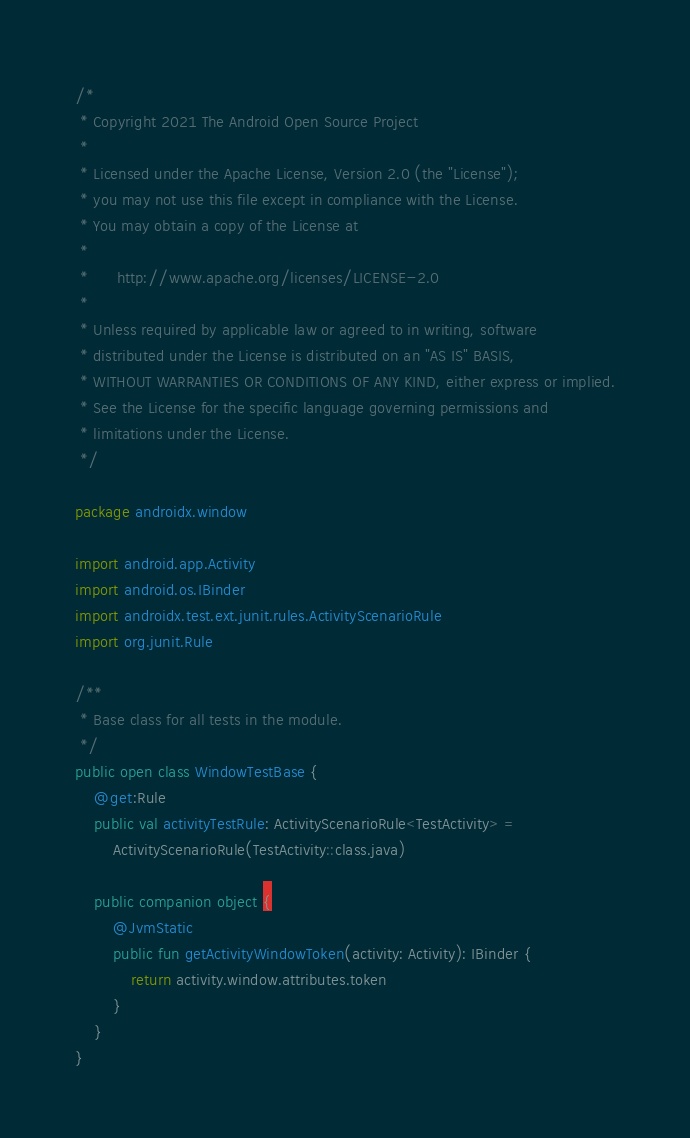Convert code to text. <code><loc_0><loc_0><loc_500><loc_500><_Kotlin_>/*
 * Copyright 2021 The Android Open Source Project
 *
 * Licensed under the Apache License, Version 2.0 (the "License");
 * you may not use this file except in compliance with the License.
 * You may obtain a copy of the License at
 *
 *      http://www.apache.org/licenses/LICENSE-2.0
 *
 * Unless required by applicable law or agreed to in writing, software
 * distributed under the License is distributed on an "AS IS" BASIS,
 * WITHOUT WARRANTIES OR CONDITIONS OF ANY KIND, either express or implied.
 * See the License for the specific language governing permissions and
 * limitations under the License.
 */

package androidx.window

import android.app.Activity
import android.os.IBinder
import androidx.test.ext.junit.rules.ActivityScenarioRule
import org.junit.Rule

/**
 * Base class for all tests in the module.
 */
public open class WindowTestBase {
    @get:Rule
    public val activityTestRule: ActivityScenarioRule<TestActivity> =
        ActivityScenarioRule(TestActivity::class.java)

    public companion object {
        @JvmStatic
        public fun getActivityWindowToken(activity: Activity): IBinder {
            return activity.window.attributes.token
        }
    }
}
</code> 